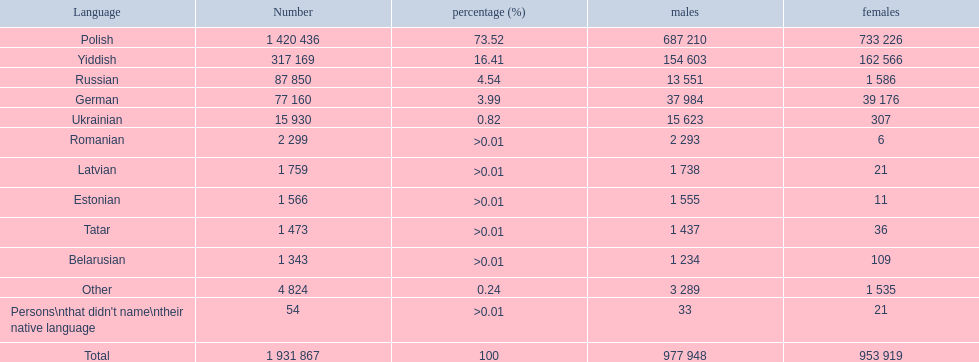Which languages had a percentage greater than 0.01? Romanian, Latvian, Estonian, Tatar, Belarusian. What was the highest-ranking language? Romanian. 